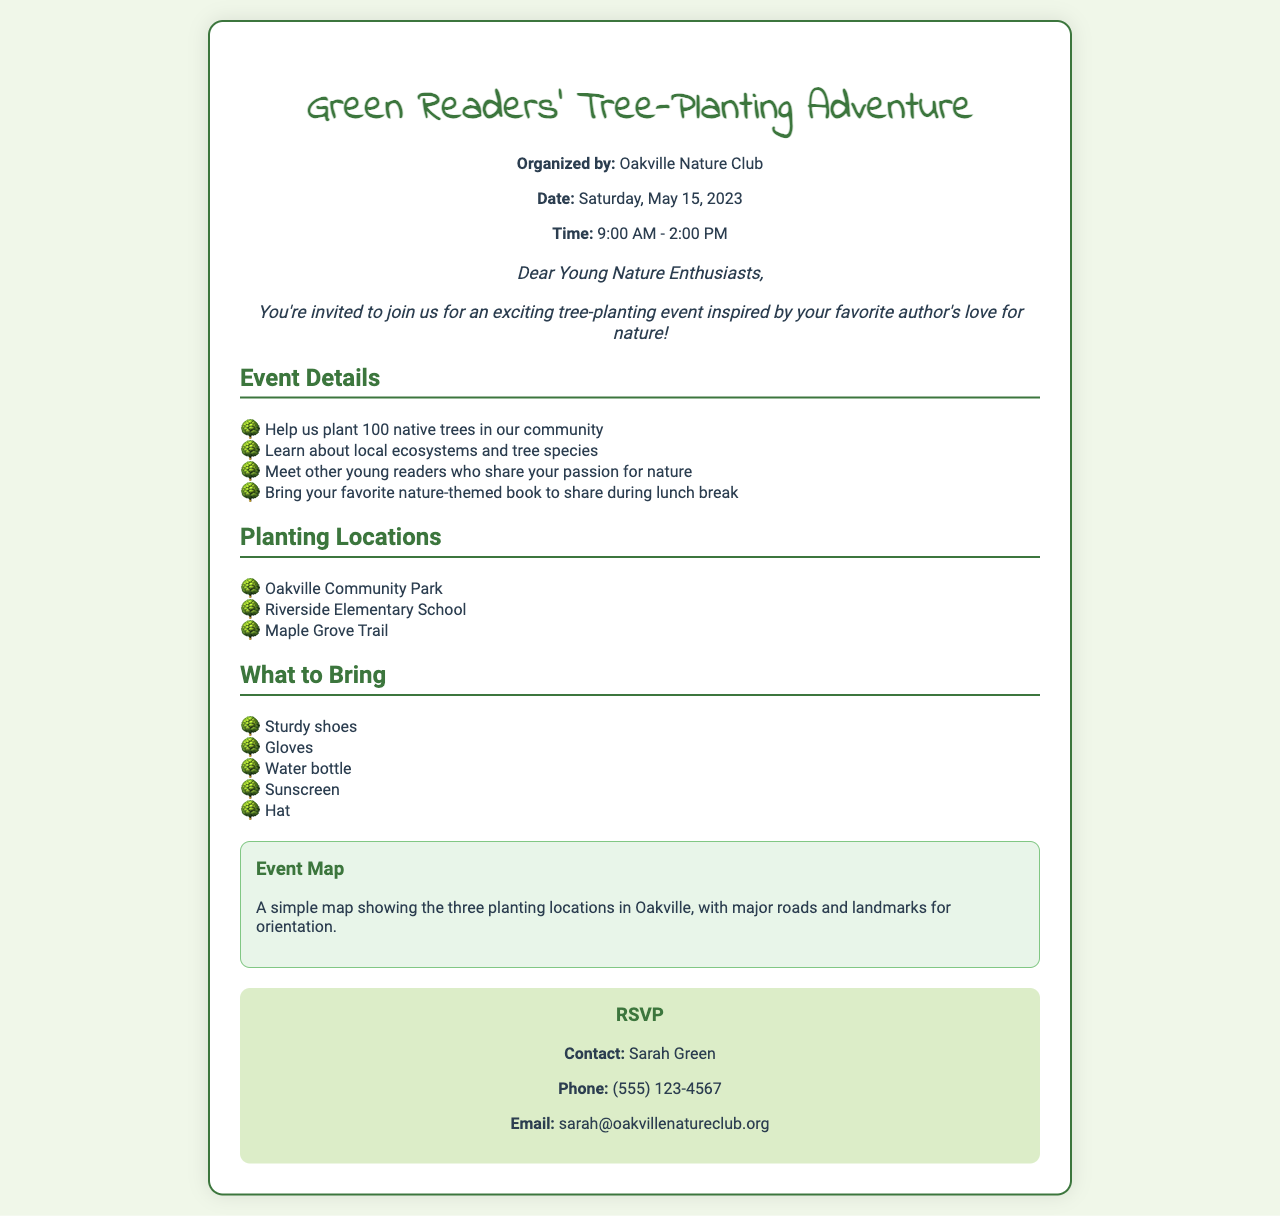What is the date of the event? The event is scheduled for Saturday, May 15, 2023.
Answer: Saturday, May 15, 2023 Who is organizing the event? The organization listed as the event organizer is the Oakville Nature Club.
Answer: Oakville Nature Club How many native trees will be planted? The document states that 100 native trees will be planted during the event.
Answer: 100 What should participants bring for lunch? Participants are encouraged to bring their favorite nature-themed book to share during lunch.
Answer: Nature-themed book Where is one of the planting locations? The document lists Oakville Community Park as one of the planting locations.
Answer: Oakville Community Park Why might this event be of interest to young readers? The event combines tree planting with the opportunity to meet other young readers and share a love for nature.
Answer: Love for nature What time does the event start? The event starts at 9:00 AM according to the document.
Answer: 9:00 AM What is the contact email for RSVPs? The RSVP contact email provided in the document is sarah@oakvillenatureclub.org.
Answer: sarah@oakvillenatureclub.org 